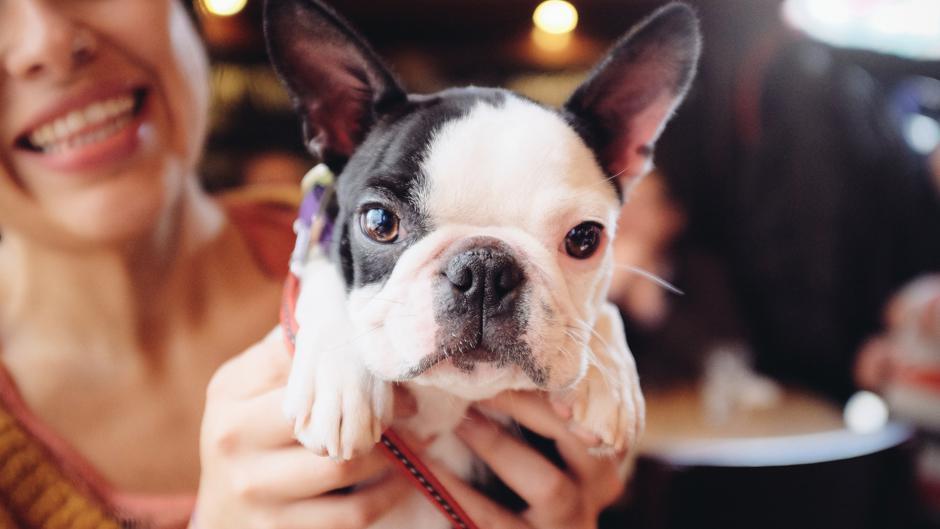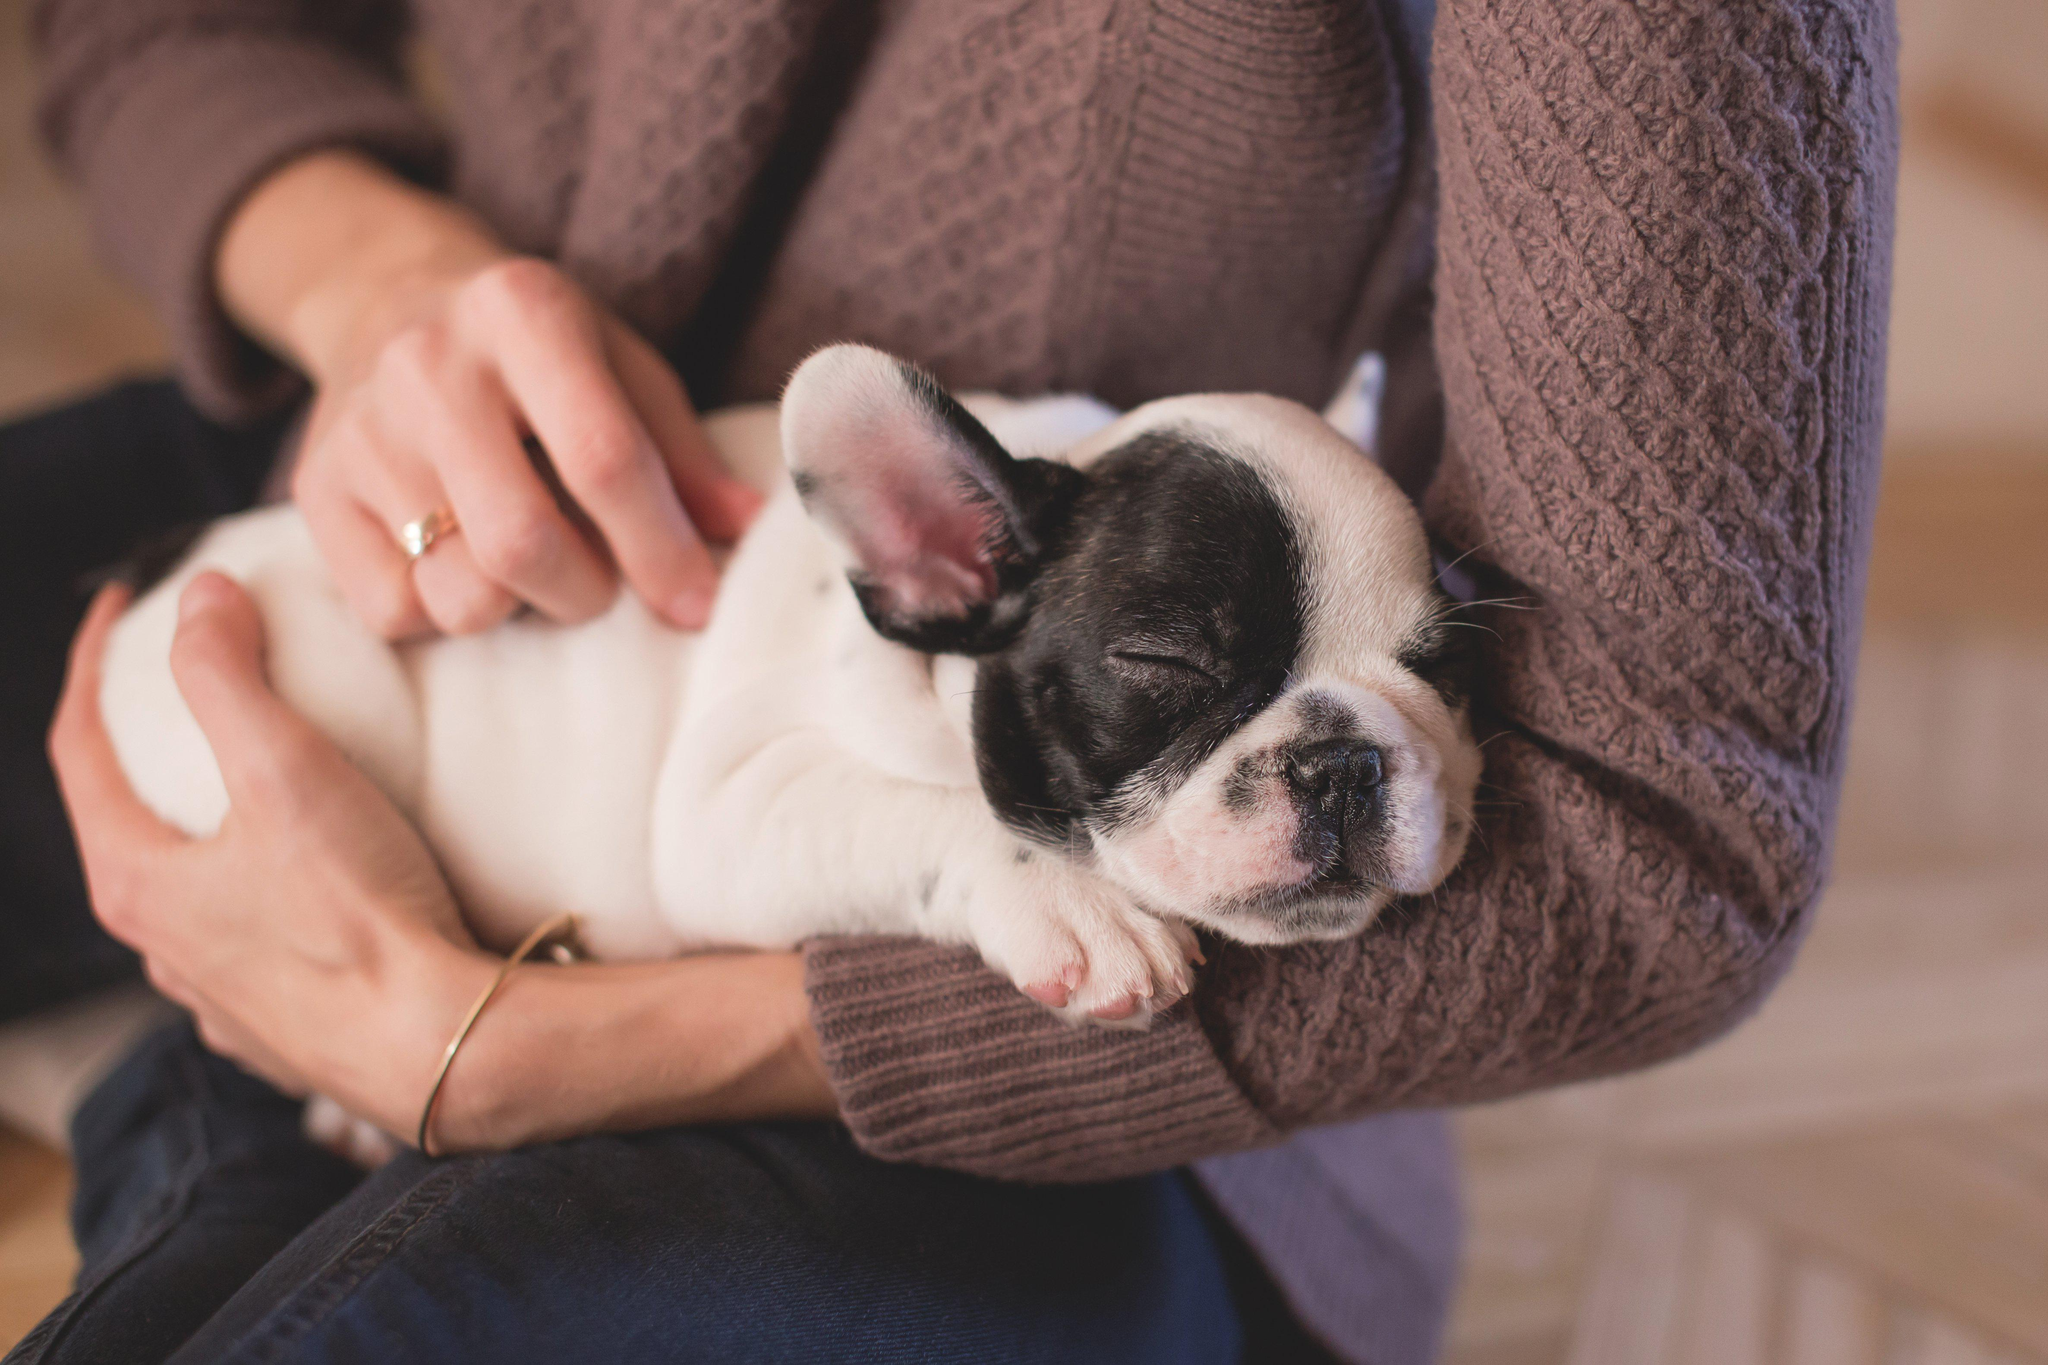The first image is the image on the left, the second image is the image on the right. Considering the images on both sides, is "The right image shows two dogs, while the left image shows just one" valid? Answer yes or no. No. The first image is the image on the left, the second image is the image on the right. For the images shown, is this caption "There are two dogs in the right image." true? Answer yes or no. No. 